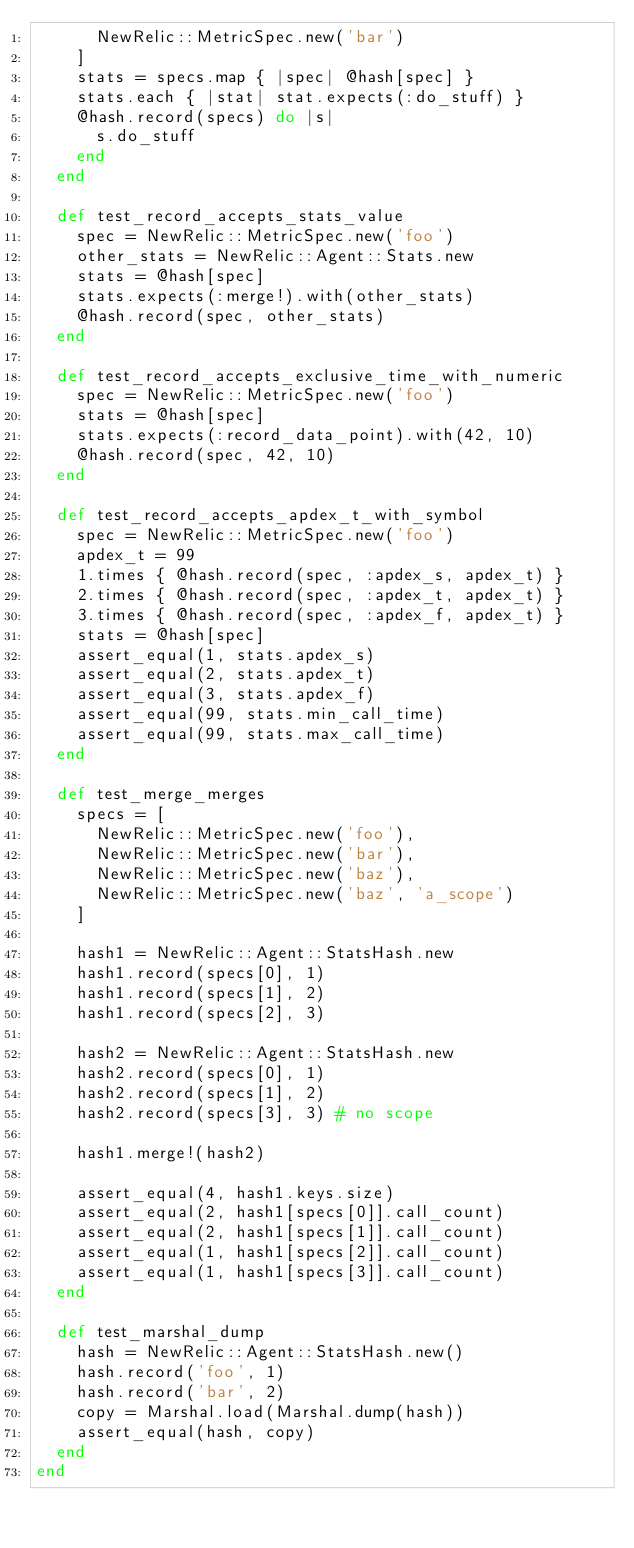<code> <loc_0><loc_0><loc_500><loc_500><_Ruby_>      NewRelic::MetricSpec.new('bar')
    ]
    stats = specs.map { |spec| @hash[spec] }
    stats.each { |stat| stat.expects(:do_stuff) }
    @hash.record(specs) do |s|
      s.do_stuff
    end
  end

  def test_record_accepts_stats_value
    spec = NewRelic::MetricSpec.new('foo')
    other_stats = NewRelic::Agent::Stats.new
    stats = @hash[spec]
    stats.expects(:merge!).with(other_stats)
    @hash.record(spec, other_stats)
  end

  def test_record_accepts_exclusive_time_with_numeric
    spec = NewRelic::MetricSpec.new('foo')
    stats = @hash[spec]
    stats.expects(:record_data_point).with(42, 10)
    @hash.record(spec, 42, 10)
  end

  def test_record_accepts_apdex_t_with_symbol
    spec = NewRelic::MetricSpec.new('foo')
    apdex_t = 99
    1.times { @hash.record(spec, :apdex_s, apdex_t) }
    2.times { @hash.record(spec, :apdex_t, apdex_t) }
    3.times { @hash.record(spec, :apdex_f, apdex_t) }
    stats = @hash[spec]
    assert_equal(1, stats.apdex_s)
    assert_equal(2, stats.apdex_t)
    assert_equal(3, stats.apdex_f)
    assert_equal(99, stats.min_call_time)
    assert_equal(99, stats.max_call_time)
  end

  def test_merge_merges
    specs = [
      NewRelic::MetricSpec.new('foo'),
      NewRelic::MetricSpec.new('bar'),
      NewRelic::MetricSpec.new('baz'),
      NewRelic::MetricSpec.new('baz', 'a_scope')
    ]

    hash1 = NewRelic::Agent::StatsHash.new
    hash1.record(specs[0], 1)
    hash1.record(specs[1], 2)
    hash1.record(specs[2], 3)

    hash2 = NewRelic::Agent::StatsHash.new
    hash2.record(specs[0], 1)
    hash2.record(specs[1], 2)
    hash2.record(specs[3], 3) # no scope

    hash1.merge!(hash2)

    assert_equal(4, hash1.keys.size)
    assert_equal(2, hash1[specs[0]].call_count)
    assert_equal(2, hash1[specs[1]].call_count)
    assert_equal(1, hash1[specs[2]].call_count)
    assert_equal(1, hash1[specs[3]].call_count)
  end

  def test_marshal_dump
    hash = NewRelic::Agent::StatsHash.new()
    hash.record('foo', 1)
    hash.record('bar', 2)
    copy = Marshal.load(Marshal.dump(hash))
    assert_equal(hash, copy)
  end
end
</code> 